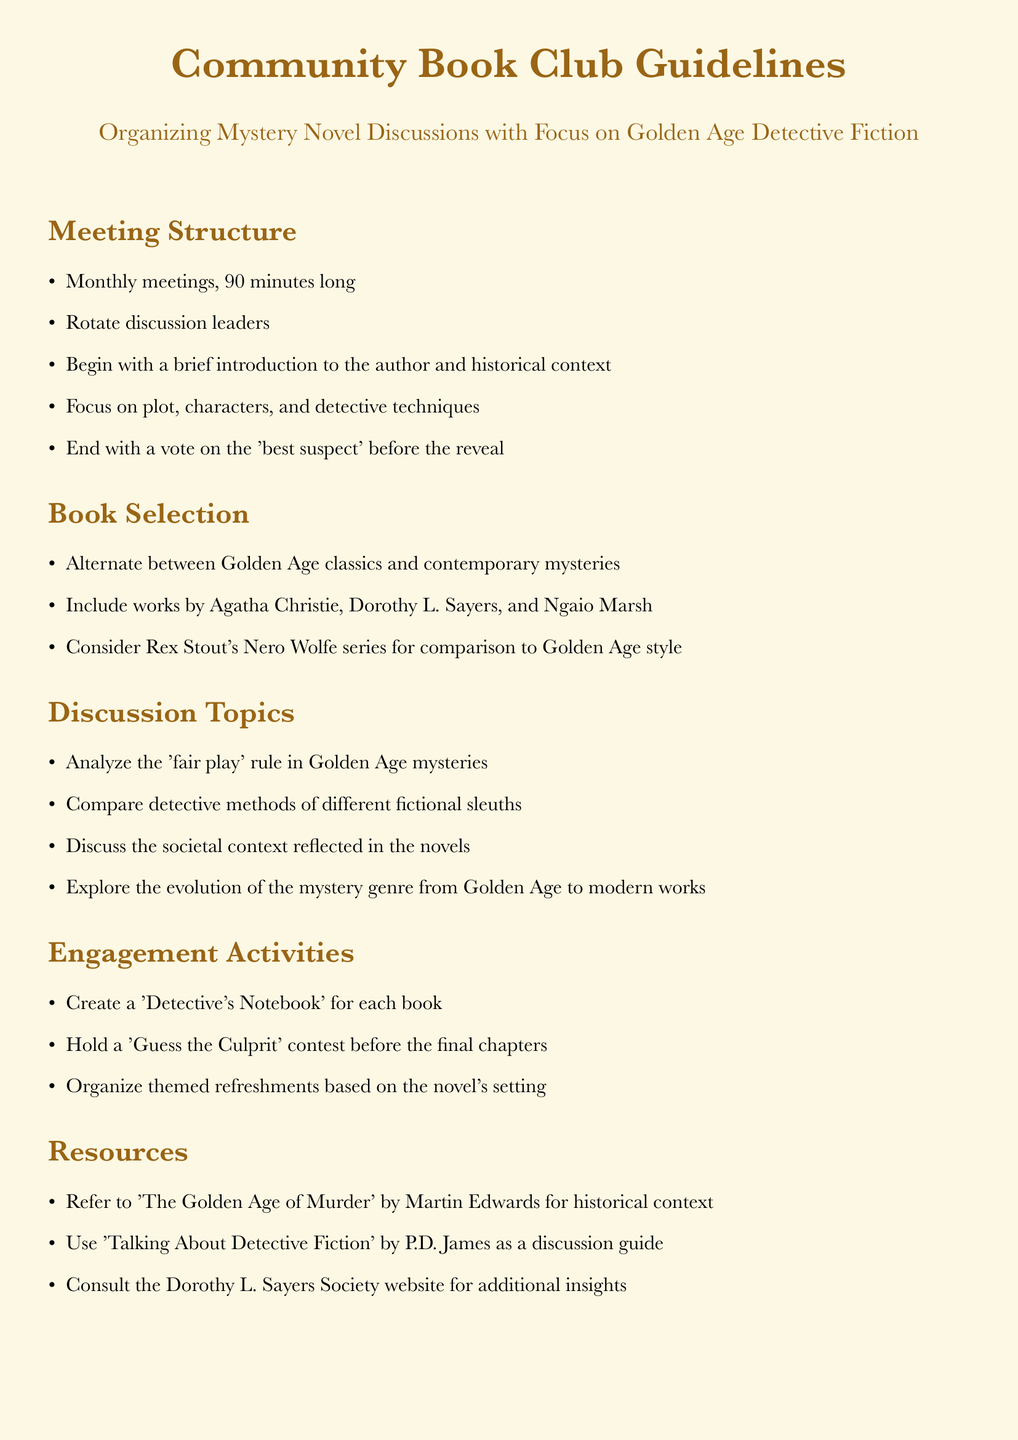What is the duration of each meeting? The document states that meetings are 90 minutes long.
Answer: 90 minutes Who are two authors mentioned for book selection? The document includes Agatha Christie and Dorothy L. Sayers as authors to consider for book selection.
Answer: Agatha Christie, Dorothy L. Sayers What activity involves a notebook? The 'Detective's Notebook' is an engagement activity mentioned in the document.
Answer: Detective's Notebook What is one analytical topic discussed in the meetings? The document states that members will analyze the 'fair play' rule in Golden Age mysteries.
Answer: 'fair play' rule How often are the meetings held? The document mentions that the meetings are held monthly.
Answer: Monthly What type of novels will be alternated in selection? The document indicates an alternation between Golden Age classics and contemporary mysteries.
Answer: Golden Age classics, contemporary mysteries What contest is organized before the final chapters? The document refers to a 'Guess the Culprit' contest as an activity conducted before the final chapters.
Answer: Guess the Culprit What is one of the resources recommended for historical context? The document recommends 'The Golden Age of Murder' by Martin Edwards for historical context.
Answer: The Golden Age of Murder 